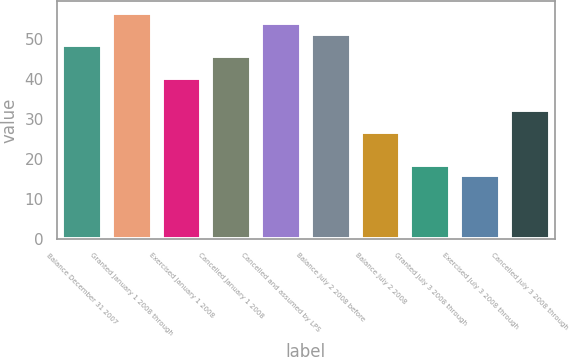<chart> <loc_0><loc_0><loc_500><loc_500><bar_chart><fcel>Balance December 31 2007<fcel>Granted January 1 2008 through<fcel>Exercised January 1 2008<fcel>Cancelled January 1 2008<fcel>Cancelled and assumed by LPS<fcel>Balance July 2 2008 before<fcel>Balance July 2 2008<fcel>Granted July 3 2008 through<fcel>Exercised July 3 2008 through<fcel>Cancelled July 3 2008 through<nl><fcel>48.38<fcel>56.51<fcel>40.25<fcel>45.67<fcel>53.8<fcel>51.09<fcel>26.7<fcel>18.57<fcel>15.86<fcel>32.12<nl></chart> 